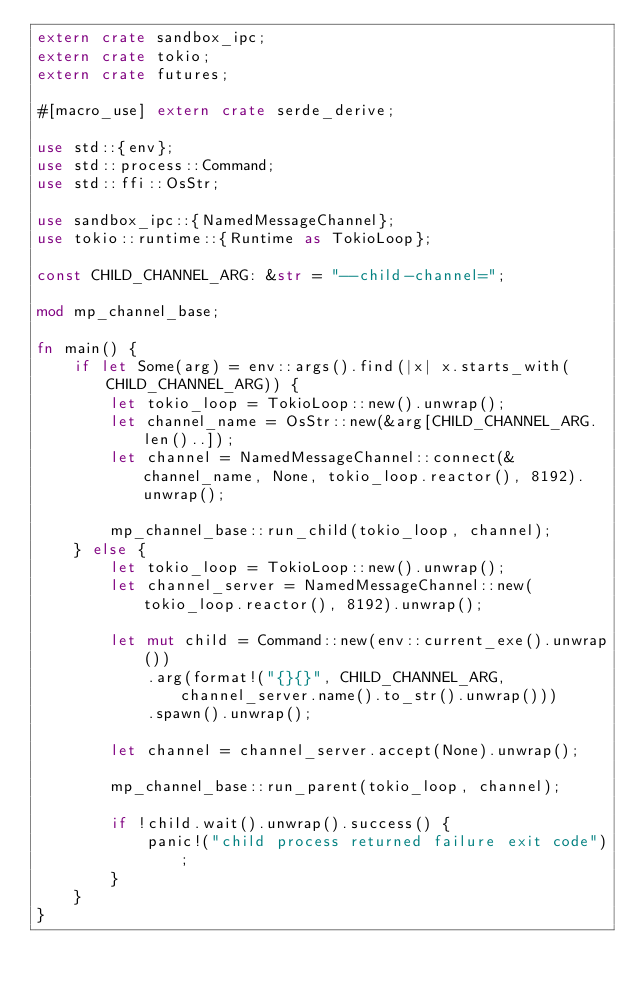Convert code to text. <code><loc_0><loc_0><loc_500><loc_500><_Rust_>extern crate sandbox_ipc;
extern crate tokio;
extern crate futures;

#[macro_use] extern crate serde_derive;

use std::{env};
use std::process::Command;
use std::ffi::OsStr;

use sandbox_ipc::{NamedMessageChannel};
use tokio::runtime::{Runtime as TokioLoop};

const CHILD_CHANNEL_ARG: &str = "--child-channel=";

mod mp_channel_base;

fn main() {
    if let Some(arg) = env::args().find(|x| x.starts_with(CHILD_CHANNEL_ARG)) {
        let tokio_loop = TokioLoop::new().unwrap();
        let channel_name = OsStr::new(&arg[CHILD_CHANNEL_ARG.len()..]);
        let channel = NamedMessageChannel::connect(&channel_name, None, tokio_loop.reactor(), 8192).unwrap();

        mp_channel_base::run_child(tokio_loop, channel);
    } else {
        let tokio_loop = TokioLoop::new().unwrap();
        let channel_server = NamedMessageChannel::new(tokio_loop.reactor(), 8192).unwrap();

        let mut child = Command::new(env::current_exe().unwrap())
            .arg(format!("{}{}", CHILD_CHANNEL_ARG, channel_server.name().to_str().unwrap()))
            .spawn().unwrap();

        let channel = channel_server.accept(None).unwrap();

        mp_channel_base::run_parent(tokio_loop, channel);

        if !child.wait().unwrap().success() {
            panic!("child process returned failure exit code");
        }
    }
}
</code> 